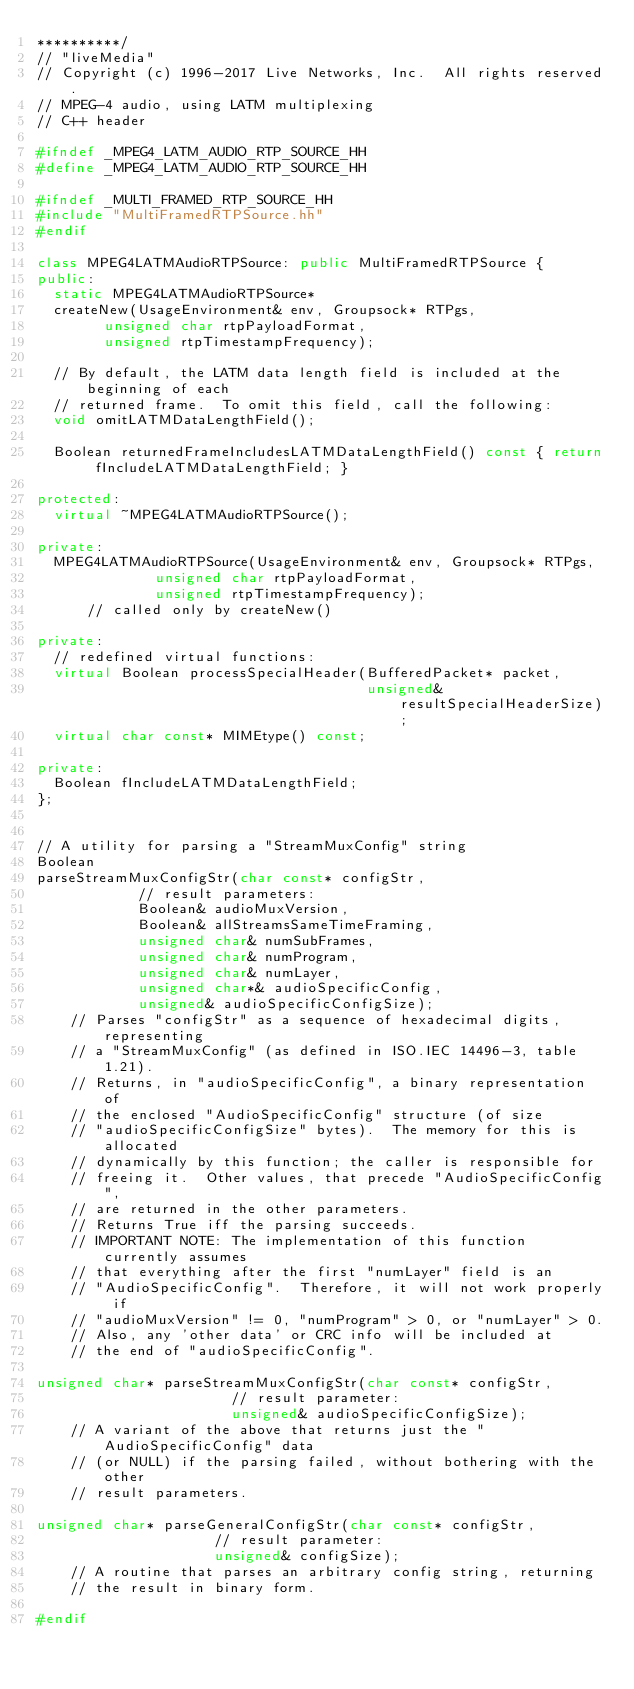<code> <loc_0><loc_0><loc_500><loc_500><_C++_>**********/
// "liveMedia"
// Copyright (c) 1996-2017 Live Networks, Inc.  All rights reserved.
// MPEG-4 audio, using LATM multiplexing
// C++ header

#ifndef _MPEG4_LATM_AUDIO_RTP_SOURCE_HH
#define _MPEG4_LATM_AUDIO_RTP_SOURCE_HH

#ifndef _MULTI_FRAMED_RTP_SOURCE_HH
#include "MultiFramedRTPSource.hh"
#endif

class MPEG4LATMAudioRTPSource: public MultiFramedRTPSource {
public:
  static MPEG4LATMAudioRTPSource*
  createNew(UsageEnvironment& env, Groupsock* RTPgs,
	    unsigned char rtpPayloadFormat,
	    unsigned rtpTimestampFrequency);

  // By default, the LATM data length field is included at the beginning of each
  // returned frame.  To omit this field, call the following:
  void omitLATMDataLengthField();

  Boolean returnedFrameIncludesLATMDataLengthField() const { return fIncludeLATMDataLengthField; }

protected:
  virtual ~MPEG4LATMAudioRTPSource();

private:
  MPEG4LATMAudioRTPSource(UsageEnvironment& env, Groupsock* RTPgs,
			  unsigned char rtpPayloadFormat,
			  unsigned rtpTimestampFrequency);
      // called only by createNew()

private:
  // redefined virtual functions:
  virtual Boolean processSpecialHeader(BufferedPacket* packet,
                                       unsigned& resultSpecialHeaderSize);
  virtual char const* MIMEtype() const;

private:
  Boolean fIncludeLATMDataLengthField;
};


// A utility for parsing a "StreamMuxConfig" string
Boolean
parseStreamMuxConfigStr(char const* configStr,
			// result parameters:
			Boolean& audioMuxVersion,
			Boolean& allStreamsSameTimeFraming,
			unsigned char& numSubFrames,
			unsigned char& numProgram,
			unsigned char& numLayer,
			unsigned char*& audioSpecificConfig,
			unsigned& audioSpecificConfigSize);
    // Parses "configStr" as a sequence of hexadecimal digits, representing
    // a "StreamMuxConfig" (as defined in ISO.IEC 14496-3, table 1.21).
    // Returns, in "audioSpecificConfig", a binary representation of
    // the enclosed "AudioSpecificConfig" structure (of size
    // "audioSpecificConfigSize" bytes).  The memory for this is allocated
    // dynamically by this function; the caller is responsible for
    // freeing it.  Other values, that precede "AudioSpecificConfig",
    // are returned in the other parameters.
    // Returns True iff the parsing succeeds.
    // IMPORTANT NOTE: The implementation of this function currently assumes
    // that everything after the first "numLayer" field is an
    // "AudioSpecificConfig".  Therefore, it will not work properly if
    // "audioMuxVersion" != 0, "numProgram" > 0, or "numLayer" > 0.
    // Also, any 'other data' or CRC info will be included at
    // the end of "audioSpecificConfig".

unsigned char* parseStreamMuxConfigStr(char const* configStr,
				       // result parameter:
				       unsigned& audioSpecificConfigSize);
    // A variant of the above that returns just the "AudioSpecificConfig" data
    // (or NULL) if the parsing failed, without bothering with the other
    // result parameters.

unsigned char* parseGeneralConfigStr(char const* configStr,
				     // result parameter:
				     unsigned& configSize);
    // A routine that parses an arbitrary config string, returning
    // the result in binary form.

#endif
</code> 